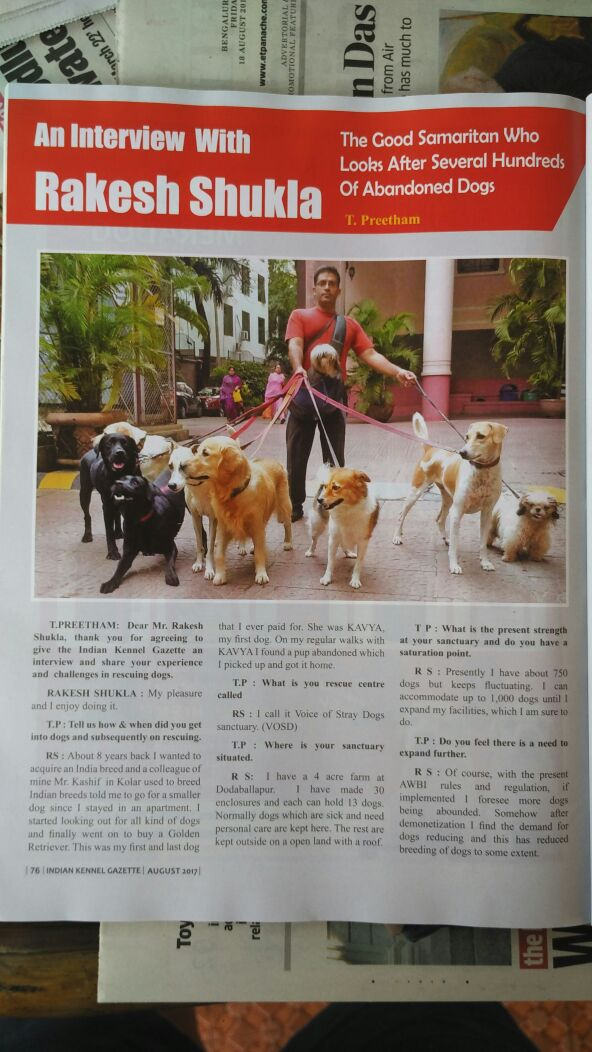Imagine the sanctuary 20 years from now. How might Rakesh Shukla's efforts and initiatives have evolved? Twenty years from now, Rakesh Shukla’s sanctuary could have evolved into a state-of-the-art animal rescue and care center, setting a benchmark for other such initiatives. With the advancements in veterinary care and technology, the sanctuary might host a comprehensive medical facility that can handle complex treatments and surgeries on-site. It could encompass various programs focused on the rehabilitative training and social integration of the dogs, preparing some for adoption while providing a lifetime home for those that are not adoptable. Educational outreach programs might be a key feature, aimed at promoting responsible pet ownership and animal welfare in the community. Furthermore, the sanctuary could have expanded significantly, possibly operating multiple locations, each tailored to specific needs such as old age homes for senior dogs, shelters for puppies, and rehabilitation centers for injured or sick animals. With increased global awareness and perhaps collaborations with international animal welfare organizations, Rakesh Shukla’s sanctuary could be a beacon of hope and a center of excellence in animal rescue and welfare. Keeping in mind the advancement of technology, how could tech innovations be incorporated into the sanctuary in the future? Tech innovations could play a transformative role in the future of Rakesh Shukla's sanctuary. Incorporating smart technology could enhance many aspects of animal care and management. For instance, RFID microchips could be used for efficient tracking and identification of the dogs, ensuring that their medical and dietary needs are promptly met. Automated feeding systems could be employed to deliver precise portions of food, tailored to each dog's nutritional requirements. Surveillance drones and AI-powered monitoring systems could help in observing the dogs' behavior and health around the clock, identifying any issues early on. Virtual reality (VR) could be used for the training and rehabilitation of dogs with behavioral problems, providing them with a controlled environment to overcome their fears and anxieties. Moreover, telemedicine platforms could enable remote consultation with veterinary specialists from around the world, ensuring that the dogs receive the best possible care. Tech innovations could also streamline administrative tasks, with AI assisting in managing records, coordinating volunteer schedules, and even helping with fundraising efforts through intelligent campaign management systems. What if Rakesh Shukla could communicate with the dogs? How would this change the dynamics of the sanctuary? If Rakesh Shukla could communicate with the dogs, it would revolutionize the dynamics of the sanctuary. Such a profound ability would allow him to understand the individual histories, traumas, and needs of each dog directly. Imagine being able to ask each dog about their past experiences and preferences, leading to more personalized care plans. Behavioral issues could be addressed with greater empathy and precision, as dogs could express their emotions and difficulties. The training and rehabilitation programs would become more effective and humane, as communication would enable a deeper bond and understanding between Rakesh and the dogs. This could also help in matching the dogs with potential adopters better, ensuring that each dog finds the most suitable home. Furthermore, it would bring to light unique stories of each dog, enriching educational and outreach programs, and fostering a more compassionate community. In essence, the sanctuary would transform into a haven where the voices of the voiceless are heard, making the mission of rescue and care more impactful and rewarding. 